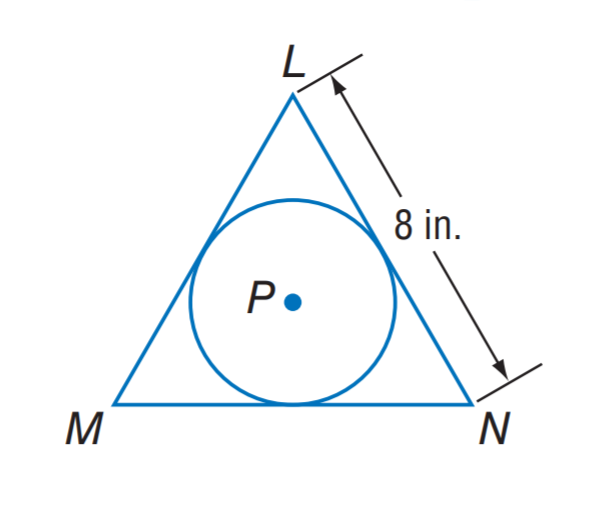Answer the mathemtical geometry problem and directly provide the correct option letter.
Question: \odot P is inscribed in equilateral triangle L M N. What is the circumference of \odot P?
Choices: A: \frac { 8 } { 3 } \pi B: \frac { 8 } { \sqrt 3 } \pi C: 8 \sqrt 3 \pi D: 24 \pi B 